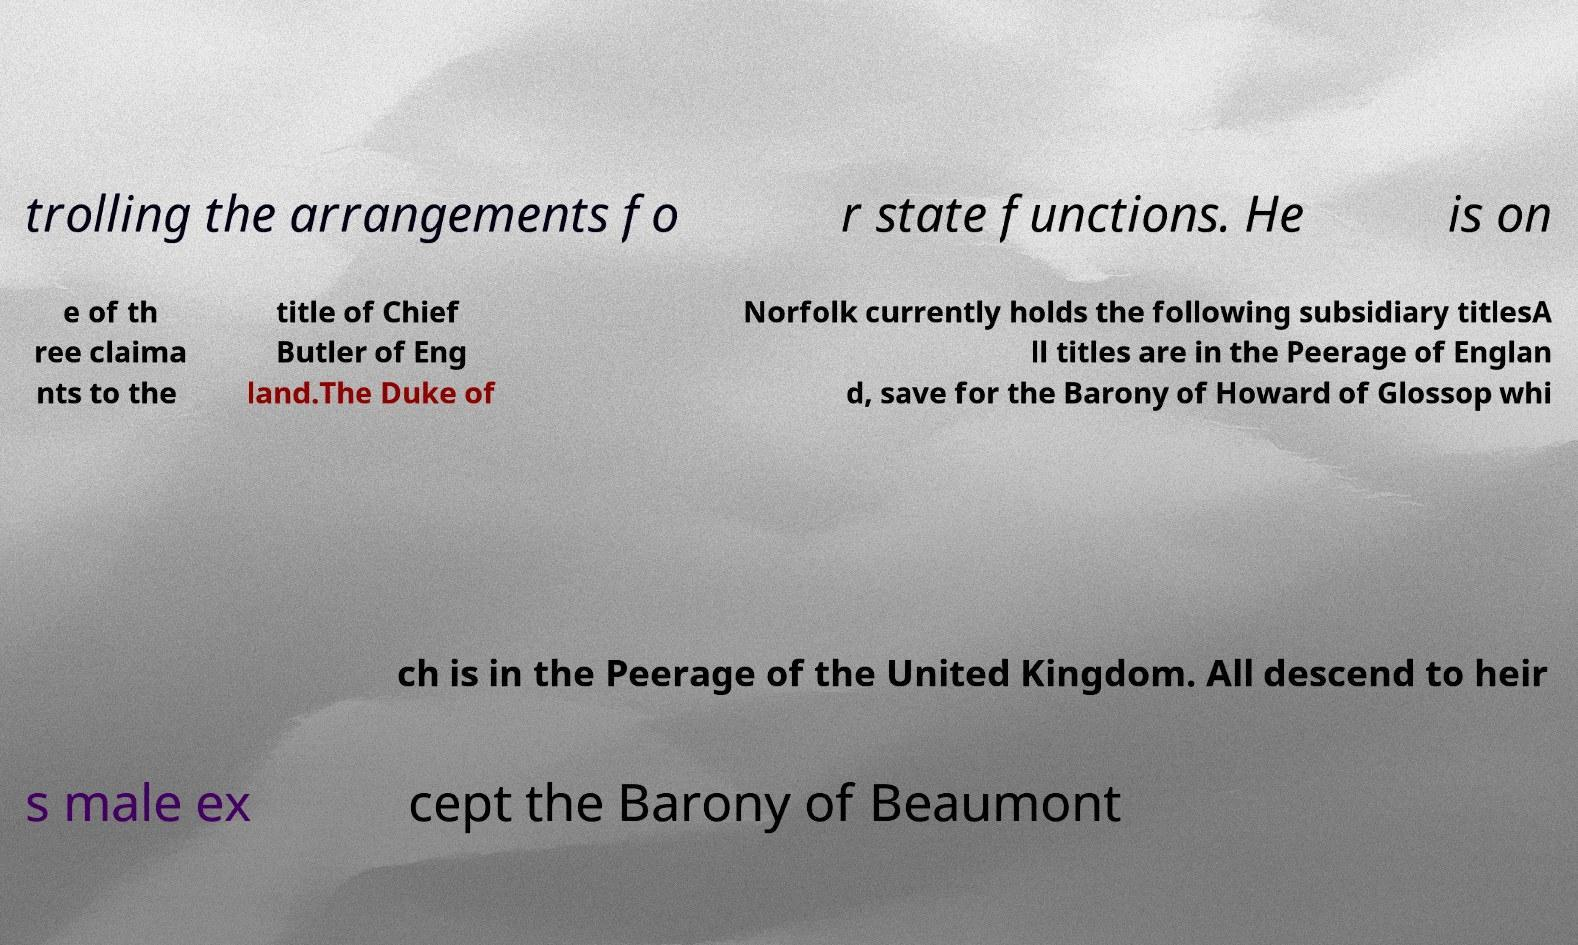Please identify and transcribe the text found in this image. trolling the arrangements fo r state functions. He is on e of th ree claima nts to the title of Chief Butler of Eng land.The Duke of Norfolk currently holds the following subsidiary titlesA ll titles are in the Peerage of Englan d, save for the Barony of Howard of Glossop whi ch is in the Peerage of the United Kingdom. All descend to heir s male ex cept the Barony of Beaumont 